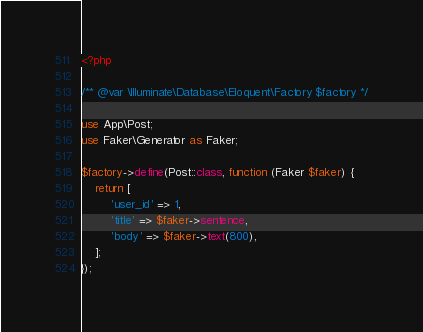<code> <loc_0><loc_0><loc_500><loc_500><_PHP_><?php

/** @var \Illuminate\Database\Eloquent\Factory $factory */

use App\Post;
use Faker\Generator as Faker;

$factory->define(Post::class, function (Faker $faker) {
    return [
        'user_id' => 1,
        'title' => $faker->sentence,
        'body' => $faker->text(800),
    ];
});
</code> 